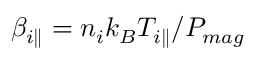Convert formula to latex. <formula><loc_0><loc_0><loc_500><loc_500>\beta _ { i \| } = n _ { i } k _ { B } T _ { i \| } / P _ { m a g }</formula> 